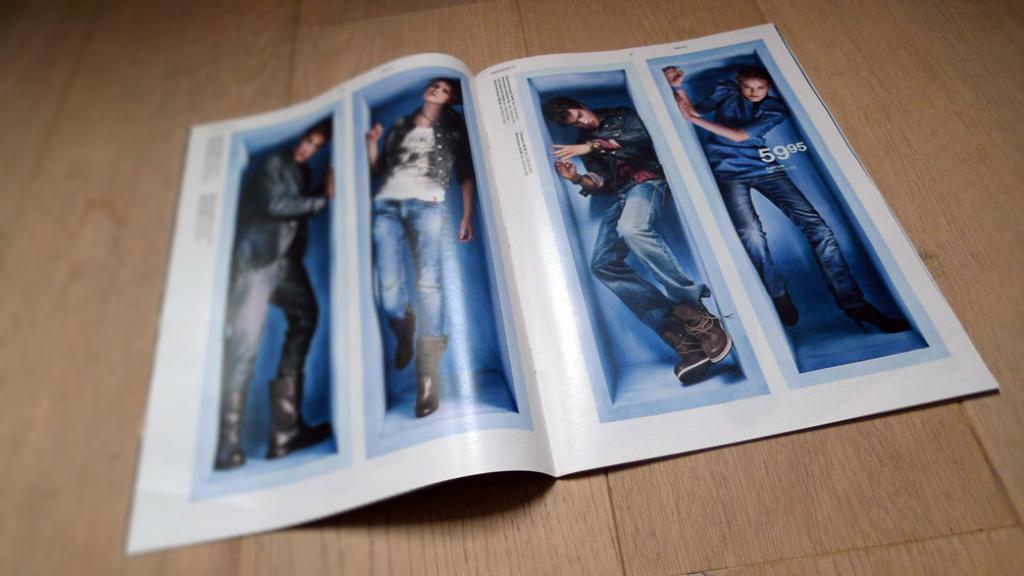How would you summarize this image in a sentence or two? In this picture we can see a poster, in this poster we can see collage of four images and some text, there are four persons in these images, at the bottom there is wooden surface. 